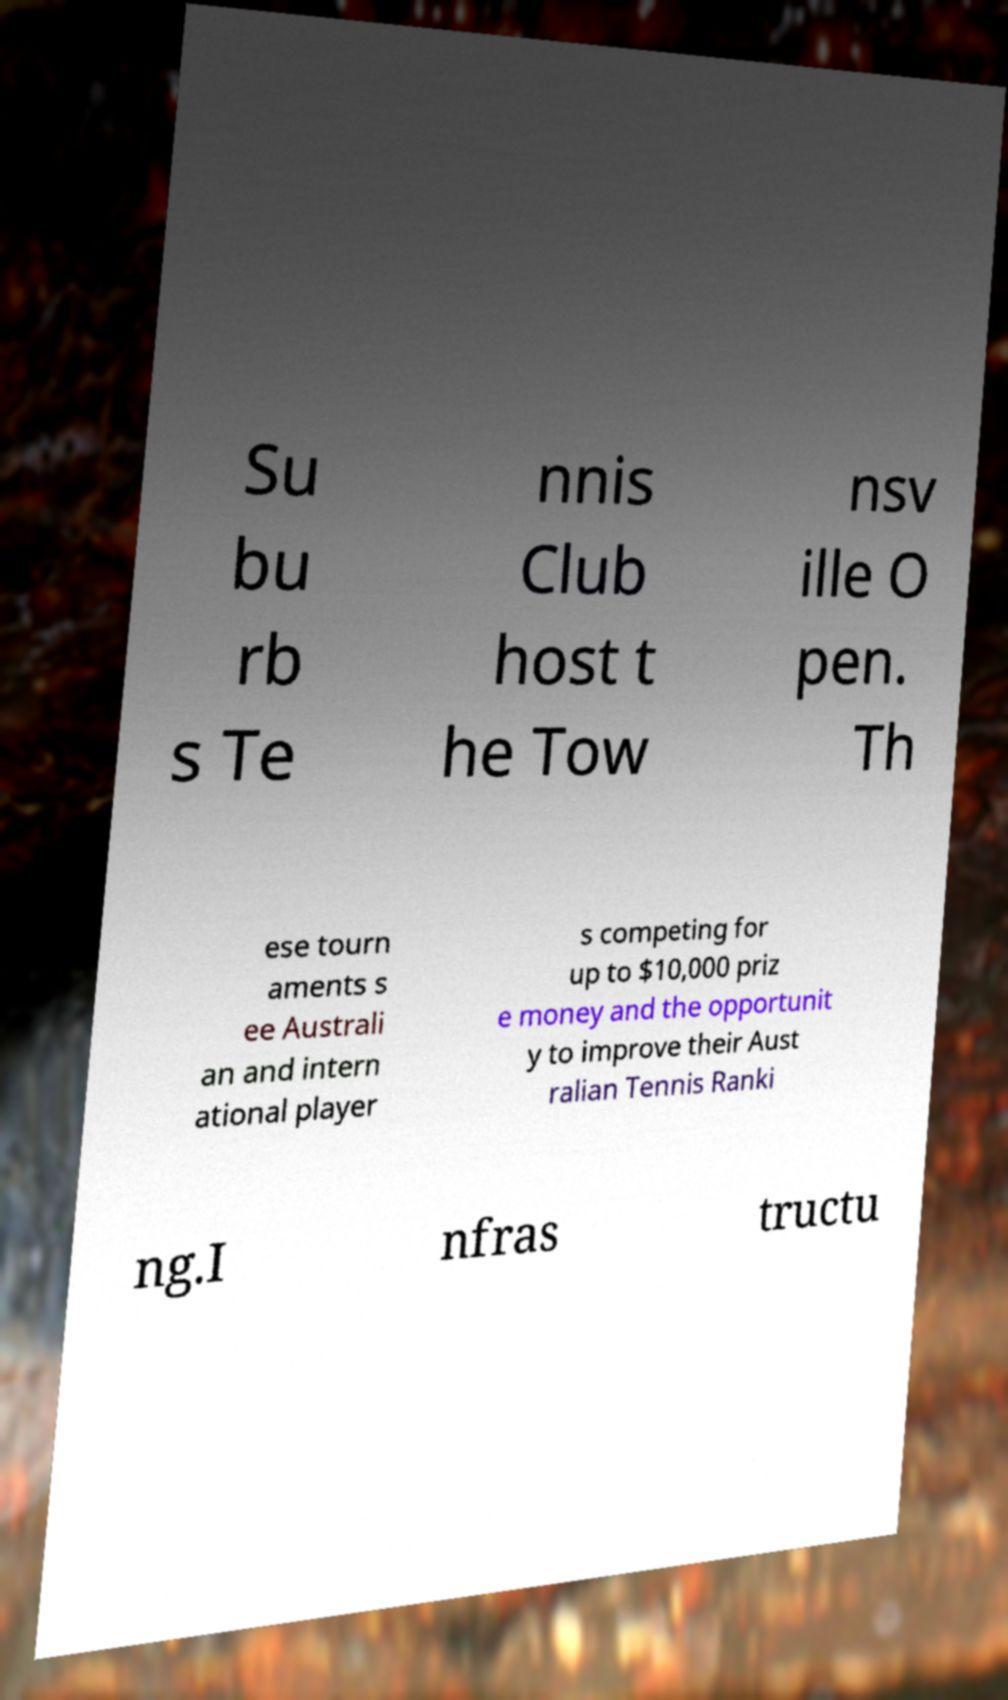What messages or text are displayed in this image? I need them in a readable, typed format. Su bu rb s Te nnis Club host t he Tow nsv ille O pen. Th ese tourn aments s ee Australi an and intern ational player s competing for up to $10,000 priz e money and the opportunit y to improve their Aust ralian Tennis Ranki ng.I nfras tructu 